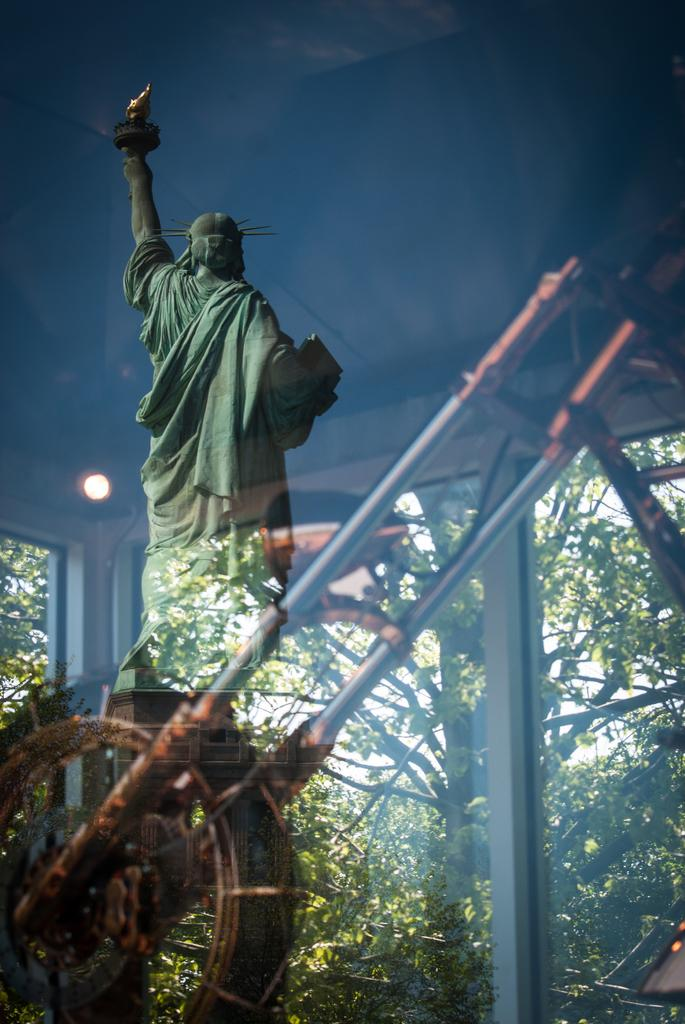What is located in the foreground of the image? There is a glass in the foreground of the image. What does the glass reflect in the image? The glass reflects a statue in the image. What type of object is behind the glass? There is a metal object behind the glass. What can be seen in the background of the image? There are trees in the background of the image. Can you hear the father crying in the image? There is no father or crying present in the image; it only features a glass, a statue, a metal object, and trees in the background. 